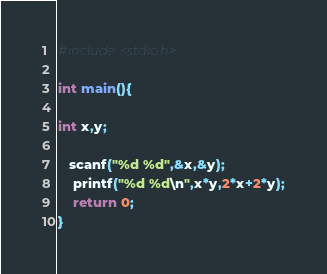<code> <loc_0><loc_0><loc_500><loc_500><_C_>#include<stdio.h>

int main(){

int x,y;

   scanf("%d %d",&x,&y);
    printf("%d %d\n",x*y,2*x+2*y);
    return 0;
}</code> 